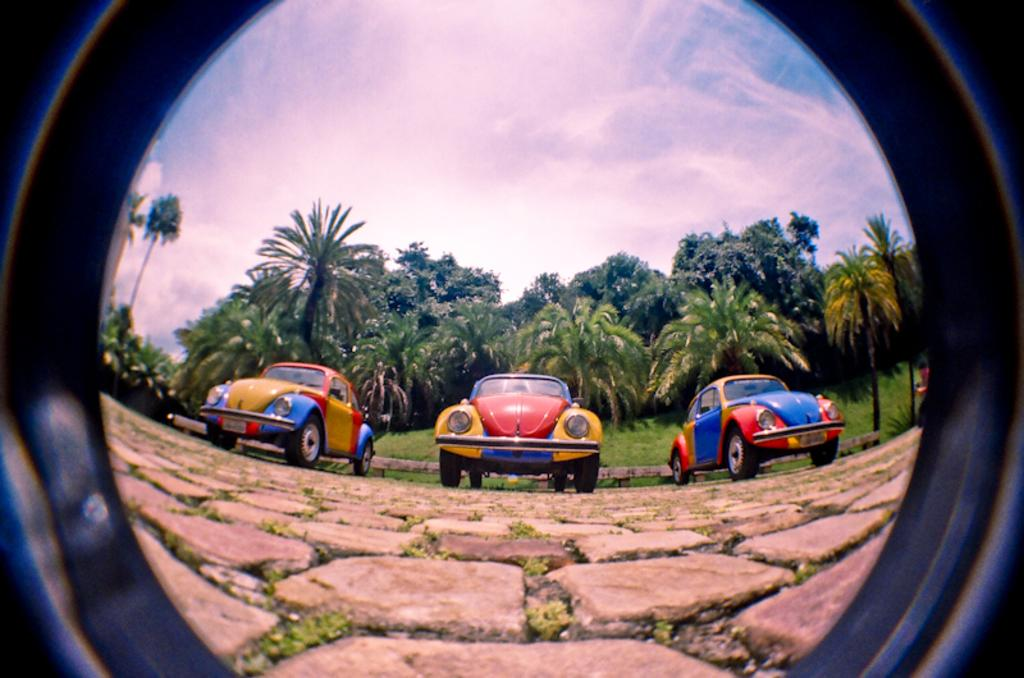What is the main subject of the image? The main subject of the image is a lens. What can be seen through the lens? Three cars are visible through the lens. Where are the cars parked? The cars are parked on a stone ground. What is visible in the background of the image? Trees and the sky are visible in the background of the image. What is the condition of the sky in the image? Clouds are present in the sky. What type of pump can be seen near the cars in the image? There is no pump present near the cars in the image. Is there a cart visible in the image? No, there is no cart visible in the image. 